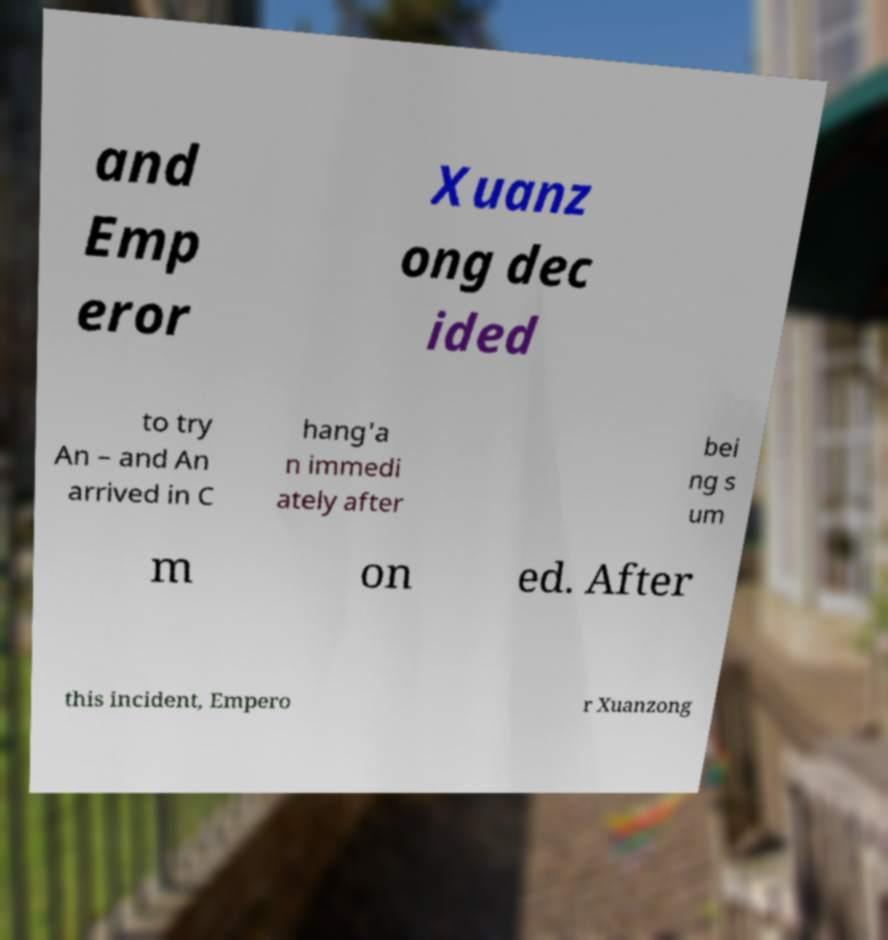There's text embedded in this image that I need extracted. Can you transcribe it verbatim? and Emp eror Xuanz ong dec ided to try An – and An arrived in C hang'a n immedi ately after bei ng s um m on ed. After this incident, Empero r Xuanzong 